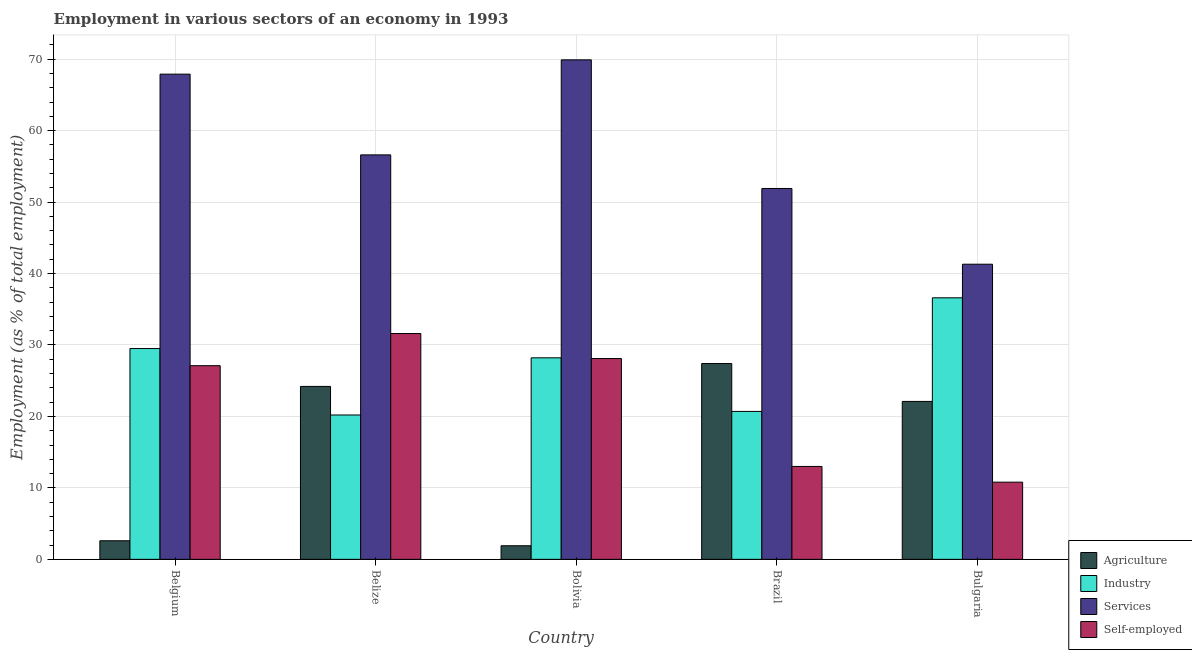Are the number of bars on each tick of the X-axis equal?
Provide a succinct answer. Yes. How many bars are there on the 5th tick from the right?
Keep it short and to the point. 4. What is the label of the 1st group of bars from the left?
Give a very brief answer. Belgium. In how many cases, is the number of bars for a given country not equal to the number of legend labels?
Provide a short and direct response. 0. What is the percentage of workers in agriculture in Belgium?
Keep it short and to the point. 2.6. Across all countries, what is the maximum percentage of workers in industry?
Ensure brevity in your answer.  36.6. Across all countries, what is the minimum percentage of workers in agriculture?
Your response must be concise. 1.9. In which country was the percentage of workers in services minimum?
Offer a terse response. Bulgaria. What is the total percentage of workers in agriculture in the graph?
Keep it short and to the point. 78.2. What is the difference between the percentage of self employed workers in Belgium and that in Bulgaria?
Offer a very short reply. 16.3. What is the difference between the percentage of workers in industry in Bolivia and the percentage of workers in services in Brazil?
Offer a terse response. -23.7. What is the average percentage of workers in services per country?
Provide a succinct answer. 57.52. What is the difference between the percentage of self employed workers and percentage of workers in services in Belize?
Ensure brevity in your answer.  -25. What is the ratio of the percentage of workers in industry in Belize to that in Brazil?
Offer a terse response. 0.98. Is the percentage of self employed workers in Belize less than that in Bolivia?
Make the answer very short. No. Is the difference between the percentage of workers in agriculture in Belgium and Bulgaria greater than the difference between the percentage of workers in services in Belgium and Bulgaria?
Offer a terse response. No. What is the difference between the highest and the second highest percentage of workers in agriculture?
Provide a short and direct response. 3.2. What is the difference between the highest and the lowest percentage of workers in services?
Your answer should be compact. 28.6. In how many countries, is the percentage of workers in industry greater than the average percentage of workers in industry taken over all countries?
Provide a short and direct response. 3. Is it the case that in every country, the sum of the percentage of workers in services and percentage of self employed workers is greater than the sum of percentage of workers in agriculture and percentage of workers in industry?
Ensure brevity in your answer.  No. What does the 3rd bar from the left in Belize represents?
Provide a succinct answer. Services. What does the 3rd bar from the right in Belize represents?
Your response must be concise. Industry. How many bars are there?
Your answer should be very brief. 20. How many countries are there in the graph?
Your answer should be very brief. 5. What is the difference between two consecutive major ticks on the Y-axis?
Offer a very short reply. 10. Are the values on the major ticks of Y-axis written in scientific E-notation?
Your answer should be compact. No. Where does the legend appear in the graph?
Give a very brief answer. Bottom right. How many legend labels are there?
Your answer should be compact. 4. What is the title of the graph?
Provide a short and direct response. Employment in various sectors of an economy in 1993. What is the label or title of the X-axis?
Provide a succinct answer. Country. What is the label or title of the Y-axis?
Offer a terse response. Employment (as % of total employment). What is the Employment (as % of total employment) of Agriculture in Belgium?
Your response must be concise. 2.6. What is the Employment (as % of total employment) in Industry in Belgium?
Keep it short and to the point. 29.5. What is the Employment (as % of total employment) of Services in Belgium?
Offer a terse response. 67.9. What is the Employment (as % of total employment) in Self-employed in Belgium?
Your answer should be very brief. 27.1. What is the Employment (as % of total employment) of Agriculture in Belize?
Provide a succinct answer. 24.2. What is the Employment (as % of total employment) in Industry in Belize?
Your answer should be compact. 20.2. What is the Employment (as % of total employment) of Services in Belize?
Offer a terse response. 56.6. What is the Employment (as % of total employment) of Self-employed in Belize?
Offer a terse response. 31.6. What is the Employment (as % of total employment) in Agriculture in Bolivia?
Your answer should be compact. 1.9. What is the Employment (as % of total employment) of Industry in Bolivia?
Make the answer very short. 28.2. What is the Employment (as % of total employment) of Services in Bolivia?
Offer a very short reply. 69.9. What is the Employment (as % of total employment) of Self-employed in Bolivia?
Provide a succinct answer. 28.1. What is the Employment (as % of total employment) in Agriculture in Brazil?
Give a very brief answer. 27.4. What is the Employment (as % of total employment) in Industry in Brazil?
Offer a terse response. 20.7. What is the Employment (as % of total employment) of Services in Brazil?
Keep it short and to the point. 51.9. What is the Employment (as % of total employment) in Agriculture in Bulgaria?
Offer a very short reply. 22.1. What is the Employment (as % of total employment) of Industry in Bulgaria?
Offer a terse response. 36.6. What is the Employment (as % of total employment) in Services in Bulgaria?
Provide a short and direct response. 41.3. What is the Employment (as % of total employment) in Self-employed in Bulgaria?
Offer a terse response. 10.8. Across all countries, what is the maximum Employment (as % of total employment) of Agriculture?
Provide a succinct answer. 27.4. Across all countries, what is the maximum Employment (as % of total employment) of Industry?
Provide a succinct answer. 36.6. Across all countries, what is the maximum Employment (as % of total employment) in Services?
Offer a terse response. 69.9. Across all countries, what is the maximum Employment (as % of total employment) in Self-employed?
Keep it short and to the point. 31.6. Across all countries, what is the minimum Employment (as % of total employment) in Agriculture?
Make the answer very short. 1.9. Across all countries, what is the minimum Employment (as % of total employment) of Industry?
Give a very brief answer. 20.2. Across all countries, what is the minimum Employment (as % of total employment) of Services?
Make the answer very short. 41.3. Across all countries, what is the minimum Employment (as % of total employment) of Self-employed?
Your answer should be compact. 10.8. What is the total Employment (as % of total employment) in Agriculture in the graph?
Offer a terse response. 78.2. What is the total Employment (as % of total employment) in Industry in the graph?
Provide a succinct answer. 135.2. What is the total Employment (as % of total employment) in Services in the graph?
Provide a succinct answer. 287.6. What is the total Employment (as % of total employment) of Self-employed in the graph?
Offer a very short reply. 110.6. What is the difference between the Employment (as % of total employment) in Agriculture in Belgium and that in Belize?
Provide a succinct answer. -21.6. What is the difference between the Employment (as % of total employment) in Services in Belgium and that in Belize?
Your response must be concise. 11.3. What is the difference between the Employment (as % of total employment) in Industry in Belgium and that in Bolivia?
Your answer should be very brief. 1.3. What is the difference between the Employment (as % of total employment) of Services in Belgium and that in Bolivia?
Your answer should be compact. -2. What is the difference between the Employment (as % of total employment) of Self-employed in Belgium and that in Bolivia?
Offer a terse response. -1. What is the difference between the Employment (as % of total employment) in Agriculture in Belgium and that in Brazil?
Provide a succinct answer. -24.8. What is the difference between the Employment (as % of total employment) of Self-employed in Belgium and that in Brazil?
Give a very brief answer. 14.1. What is the difference between the Employment (as % of total employment) in Agriculture in Belgium and that in Bulgaria?
Offer a very short reply. -19.5. What is the difference between the Employment (as % of total employment) in Industry in Belgium and that in Bulgaria?
Your answer should be compact. -7.1. What is the difference between the Employment (as % of total employment) of Services in Belgium and that in Bulgaria?
Ensure brevity in your answer.  26.6. What is the difference between the Employment (as % of total employment) of Agriculture in Belize and that in Bolivia?
Your response must be concise. 22.3. What is the difference between the Employment (as % of total employment) in Self-employed in Belize and that in Bolivia?
Your response must be concise. 3.5. What is the difference between the Employment (as % of total employment) in Agriculture in Belize and that in Brazil?
Make the answer very short. -3.2. What is the difference between the Employment (as % of total employment) in Industry in Belize and that in Brazil?
Give a very brief answer. -0.5. What is the difference between the Employment (as % of total employment) in Services in Belize and that in Brazil?
Keep it short and to the point. 4.7. What is the difference between the Employment (as % of total employment) of Self-employed in Belize and that in Brazil?
Offer a very short reply. 18.6. What is the difference between the Employment (as % of total employment) of Industry in Belize and that in Bulgaria?
Keep it short and to the point. -16.4. What is the difference between the Employment (as % of total employment) in Services in Belize and that in Bulgaria?
Make the answer very short. 15.3. What is the difference between the Employment (as % of total employment) of Self-employed in Belize and that in Bulgaria?
Ensure brevity in your answer.  20.8. What is the difference between the Employment (as % of total employment) of Agriculture in Bolivia and that in Brazil?
Your answer should be compact. -25.5. What is the difference between the Employment (as % of total employment) in Self-employed in Bolivia and that in Brazil?
Your answer should be very brief. 15.1. What is the difference between the Employment (as % of total employment) in Agriculture in Bolivia and that in Bulgaria?
Your answer should be very brief. -20.2. What is the difference between the Employment (as % of total employment) of Services in Bolivia and that in Bulgaria?
Your answer should be compact. 28.6. What is the difference between the Employment (as % of total employment) in Agriculture in Brazil and that in Bulgaria?
Offer a very short reply. 5.3. What is the difference between the Employment (as % of total employment) of Industry in Brazil and that in Bulgaria?
Offer a terse response. -15.9. What is the difference between the Employment (as % of total employment) of Self-employed in Brazil and that in Bulgaria?
Provide a short and direct response. 2.2. What is the difference between the Employment (as % of total employment) in Agriculture in Belgium and the Employment (as % of total employment) in Industry in Belize?
Offer a terse response. -17.6. What is the difference between the Employment (as % of total employment) of Agriculture in Belgium and the Employment (as % of total employment) of Services in Belize?
Your response must be concise. -54. What is the difference between the Employment (as % of total employment) of Agriculture in Belgium and the Employment (as % of total employment) of Self-employed in Belize?
Offer a terse response. -29. What is the difference between the Employment (as % of total employment) in Industry in Belgium and the Employment (as % of total employment) in Services in Belize?
Provide a succinct answer. -27.1. What is the difference between the Employment (as % of total employment) of Industry in Belgium and the Employment (as % of total employment) of Self-employed in Belize?
Offer a very short reply. -2.1. What is the difference between the Employment (as % of total employment) of Services in Belgium and the Employment (as % of total employment) of Self-employed in Belize?
Make the answer very short. 36.3. What is the difference between the Employment (as % of total employment) of Agriculture in Belgium and the Employment (as % of total employment) of Industry in Bolivia?
Offer a terse response. -25.6. What is the difference between the Employment (as % of total employment) in Agriculture in Belgium and the Employment (as % of total employment) in Services in Bolivia?
Give a very brief answer. -67.3. What is the difference between the Employment (as % of total employment) in Agriculture in Belgium and the Employment (as % of total employment) in Self-employed in Bolivia?
Make the answer very short. -25.5. What is the difference between the Employment (as % of total employment) in Industry in Belgium and the Employment (as % of total employment) in Services in Bolivia?
Give a very brief answer. -40.4. What is the difference between the Employment (as % of total employment) in Services in Belgium and the Employment (as % of total employment) in Self-employed in Bolivia?
Make the answer very short. 39.8. What is the difference between the Employment (as % of total employment) of Agriculture in Belgium and the Employment (as % of total employment) of Industry in Brazil?
Offer a terse response. -18.1. What is the difference between the Employment (as % of total employment) in Agriculture in Belgium and the Employment (as % of total employment) in Services in Brazil?
Make the answer very short. -49.3. What is the difference between the Employment (as % of total employment) of Agriculture in Belgium and the Employment (as % of total employment) of Self-employed in Brazil?
Make the answer very short. -10.4. What is the difference between the Employment (as % of total employment) of Industry in Belgium and the Employment (as % of total employment) of Services in Brazil?
Offer a terse response. -22.4. What is the difference between the Employment (as % of total employment) in Industry in Belgium and the Employment (as % of total employment) in Self-employed in Brazil?
Your answer should be very brief. 16.5. What is the difference between the Employment (as % of total employment) of Services in Belgium and the Employment (as % of total employment) of Self-employed in Brazil?
Offer a terse response. 54.9. What is the difference between the Employment (as % of total employment) of Agriculture in Belgium and the Employment (as % of total employment) of Industry in Bulgaria?
Offer a very short reply. -34. What is the difference between the Employment (as % of total employment) of Agriculture in Belgium and the Employment (as % of total employment) of Services in Bulgaria?
Make the answer very short. -38.7. What is the difference between the Employment (as % of total employment) of Services in Belgium and the Employment (as % of total employment) of Self-employed in Bulgaria?
Offer a terse response. 57.1. What is the difference between the Employment (as % of total employment) of Agriculture in Belize and the Employment (as % of total employment) of Industry in Bolivia?
Your response must be concise. -4. What is the difference between the Employment (as % of total employment) of Agriculture in Belize and the Employment (as % of total employment) of Services in Bolivia?
Your answer should be very brief. -45.7. What is the difference between the Employment (as % of total employment) of Agriculture in Belize and the Employment (as % of total employment) of Self-employed in Bolivia?
Offer a very short reply. -3.9. What is the difference between the Employment (as % of total employment) in Industry in Belize and the Employment (as % of total employment) in Services in Bolivia?
Make the answer very short. -49.7. What is the difference between the Employment (as % of total employment) in Services in Belize and the Employment (as % of total employment) in Self-employed in Bolivia?
Offer a terse response. 28.5. What is the difference between the Employment (as % of total employment) of Agriculture in Belize and the Employment (as % of total employment) of Services in Brazil?
Provide a short and direct response. -27.7. What is the difference between the Employment (as % of total employment) in Industry in Belize and the Employment (as % of total employment) in Services in Brazil?
Make the answer very short. -31.7. What is the difference between the Employment (as % of total employment) of Industry in Belize and the Employment (as % of total employment) of Self-employed in Brazil?
Ensure brevity in your answer.  7.2. What is the difference between the Employment (as % of total employment) of Services in Belize and the Employment (as % of total employment) of Self-employed in Brazil?
Your answer should be very brief. 43.6. What is the difference between the Employment (as % of total employment) of Agriculture in Belize and the Employment (as % of total employment) of Industry in Bulgaria?
Offer a very short reply. -12.4. What is the difference between the Employment (as % of total employment) of Agriculture in Belize and the Employment (as % of total employment) of Services in Bulgaria?
Offer a terse response. -17.1. What is the difference between the Employment (as % of total employment) of Agriculture in Belize and the Employment (as % of total employment) of Self-employed in Bulgaria?
Keep it short and to the point. 13.4. What is the difference between the Employment (as % of total employment) of Industry in Belize and the Employment (as % of total employment) of Services in Bulgaria?
Your response must be concise. -21.1. What is the difference between the Employment (as % of total employment) in Services in Belize and the Employment (as % of total employment) in Self-employed in Bulgaria?
Your answer should be very brief. 45.8. What is the difference between the Employment (as % of total employment) in Agriculture in Bolivia and the Employment (as % of total employment) in Industry in Brazil?
Your response must be concise. -18.8. What is the difference between the Employment (as % of total employment) of Agriculture in Bolivia and the Employment (as % of total employment) of Self-employed in Brazil?
Provide a succinct answer. -11.1. What is the difference between the Employment (as % of total employment) in Industry in Bolivia and the Employment (as % of total employment) in Services in Brazil?
Give a very brief answer. -23.7. What is the difference between the Employment (as % of total employment) of Services in Bolivia and the Employment (as % of total employment) of Self-employed in Brazil?
Make the answer very short. 56.9. What is the difference between the Employment (as % of total employment) of Agriculture in Bolivia and the Employment (as % of total employment) of Industry in Bulgaria?
Your answer should be compact. -34.7. What is the difference between the Employment (as % of total employment) of Agriculture in Bolivia and the Employment (as % of total employment) of Services in Bulgaria?
Your response must be concise. -39.4. What is the difference between the Employment (as % of total employment) in Industry in Bolivia and the Employment (as % of total employment) in Services in Bulgaria?
Your response must be concise. -13.1. What is the difference between the Employment (as % of total employment) in Services in Bolivia and the Employment (as % of total employment) in Self-employed in Bulgaria?
Your answer should be very brief. 59.1. What is the difference between the Employment (as % of total employment) in Agriculture in Brazil and the Employment (as % of total employment) in Industry in Bulgaria?
Keep it short and to the point. -9.2. What is the difference between the Employment (as % of total employment) in Agriculture in Brazil and the Employment (as % of total employment) in Services in Bulgaria?
Your response must be concise. -13.9. What is the difference between the Employment (as % of total employment) of Industry in Brazil and the Employment (as % of total employment) of Services in Bulgaria?
Your answer should be compact. -20.6. What is the difference between the Employment (as % of total employment) of Services in Brazil and the Employment (as % of total employment) of Self-employed in Bulgaria?
Your answer should be compact. 41.1. What is the average Employment (as % of total employment) of Agriculture per country?
Your answer should be very brief. 15.64. What is the average Employment (as % of total employment) of Industry per country?
Give a very brief answer. 27.04. What is the average Employment (as % of total employment) in Services per country?
Provide a short and direct response. 57.52. What is the average Employment (as % of total employment) in Self-employed per country?
Your response must be concise. 22.12. What is the difference between the Employment (as % of total employment) in Agriculture and Employment (as % of total employment) in Industry in Belgium?
Keep it short and to the point. -26.9. What is the difference between the Employment (as % of total employment) of Agriculture and Employment (as % of total employment) of Services in Belgium?
Keep it short and to the point. -65.3. What is the difference between the Employment (as % of total employment) in Agriculture and Employment (as % of total employment) in Self-employed in Belgium?
Provide a succinct answer. -24.5. What is the difference between the Employment (as % of total employment) in Industry and Employment (as % of total employment) in Services in Belgium?
Your answer should be very brief. -38.4. What is the difference between the Employment (as % of total employment) in Services and Employment (as % of total employment) in Self-employed in Belgium?
Keep it short and to the point. 40.8. What is the difference between the Employment (as % of total employment) in Agriculture and Employment (as % of total employment) in Services in Belize?
Make the answer very short. -32.4. What is the difference between the Employment (as % of total employment) in Agriculture and Employment (as % of total employment) in Self-employed in Belize?
Make the answer very short. -7.4. What is the difference between the Employment (as % of total employment) of Industry and Employment (as % of total employment) of Services in Belize?
Offer a very short reply. -36.4. What is the difference between the Employment (as % of total employment) of Industry and Employment (as % of total employment) of Self-employed in Belize?
Give a very brief answer. -11.4. What is the difference between the Employment (as % of total employment) of Agriculture and Employment (as % of total employment) of Industry in Bolivia?
Your response must be concise. -26.3. What is the difference between the Employment (as % of total employment) of Agriculture and Employment (as % of total employment) of Services in Bolivia?
Offer a terse response. -68. What is the difference between the Employment (as % of total employment) in Agriculture and Employment (as % of total employment) in Self-employed in Bolivia?
Provide a succinct answer. -26.2. What is the difference between the Employment (as % of total employment) of Industry and Employment (as % of total employment) of Services in Bolivia?
Your answer should be very brief. -41.7. What is the difference between the Employment (as % of total employment) in Services and Employment (as % of total employment) in Self-employed in Bolivia?
Offer a terse response. 41.8. What is the difference between the Employment (as % of total employment) in Agriculture and Employment (as % of total employment) in Services in Brazil?
Give a very brief answer. -24.5. What is the difference between the Employment (as % of total employment) of Agriculture and Employment (as % of total employment) of Self-employed in Brazil?
Your response must be concise. 14.4. What is the difference between the Employment (as % of total employment) in Industry and Employment (as % of total employment) in Services in Brazil?
Ensure brevity in your answer.  -31.2. What is the difference between the Employment (as % of total employment) in Industry and Employment (as % of total employment) in Self-employed in Brazil?
Make the answer very short. 7.7. What is the difference between the Employment (as % of total employment) of Services and Employment (as % of total employment) of Self-employed in Brazil?
Provide a short and direct response. 38.9. What is the difference between the Employment (as % of total employment) in Agriculture and Employment (as % of total employment) in Services in Bulgaria?
Offer a terse response. -19.2. What is the difference between the Employment (as % of total employment) in Industry and Employment (as % of total employment) in Self-employed in Bulgaria?
Give a very brief answer. 25.8. What is the difference between the Employment (as % of total employment) in Services and Employment (as % of total employment) in Self-employed in Bulgaria?
Provide a succinct answer. 30.5. What is the ratio of the Employment (as % of total employment) of Agriculture in Belgium to that in Belize?
Provide a succinct answer. 0.11. What is the ratio of the Employment (as % of total employment) of Industry in Belgium to that in Belize?
Your answer should be very brief. 1.46. What is the ratio of the Employment (as % of total employment) in Services in Belgium to that in Belize?
Provide a short and direct response. 1.2. What is the ratio of the Employment (as % of total employment) of Self-employed in Belgium to that in Belize?
Your response must be concise. 0.86. What is the ratio of the Employment (as % of total employment) in Agriculture in Belgium to that in Bolivia?
Offer a terse response. 1.37. What is the ratio of the Employment (as % of total employment) of Industry in Belgium to that in Bolivia?
Offer a terse response. 1.05. What is the ratio of the Employment (as % of total employment) of Services in Belgium to that in Bolivia?
Your answer should be compact. 0.97. What is the ratio of the Employment (as % of total employment) in Self-employed in Belgium to that in Bolivia?
Offer a terse response. 0.96. What is the ratio of the Employment (as % of total employment) of Agriculture in Belgium to that in Brazil?
Your answer should be compact. 0.09. What is the ratio of the Employment (as % of total employment) in Industry in Belgium to that in Brazil?
Your answer should be compact. 1.43. What is the ratio of the Employment (as % of total employment) in Services in Belgium to that in Brazil?
Keep it short and to the point. 1.31. What is the ratio of the Employment (as % of total employment) of Self-employed in Belgium to that in Brazil?
Your answer should be very brief. 2.08. What is the ratio of the Employment (as % of total employment) in Agriculture in Belgium to that in Bulgaria?
Give a very brief answer. 0.12. What is the ratio of the Employment (as % of total employment) in Industry in Belgium to that in Bulgaria?
Ensure brevity in your answer.  0.81. What is the ratio of the Employment (as % of total employment) of Services in Belgium to that in Bulgaria?
Provide a short and direct response. 1.64. What is the ratio of the Employment (as % of total employment) of Self-employed in Belgium to that in Bulgaria?
Your response must be concise. 2.51. What is the ratio of the Employment (as % of total employment) in Agriculture in Belize to that in Bolivia?
Offer a terse response. 12.74. What is the ratio of the Employment (as % of total employment) in Industry in Belize to that in Bolivia?
Your answer should be very brief. 0.72. What is the ratio of the Employment (as % of total employment) in Services in Belize to that in Bolivia?
Provide a short and direct response. 0.81. What is the ratio of the Employment (as % of total employment) in Self-employed in Belize to that in Bolivia?
Offer a terse response. 1.12. What is the ratio of the Employment (as % of total employment) of Agriculture in Belize to that in Brazil?
Provide a succinct answer. 0.88. What is the ratio of the Employment (as % of total employment) of Industry in Belize to that in Brazil?
Make the answer very short. 0.98. What is the ratio of the Employment (as % of total employment) of Services in Belize to that in Brazil?
Keep it short and to the point. 1.09. What is the ratio of the Employment (as % of total employment) in Self-employed in Belize to that in Brazil?
Make the answer very short. 2.43. What is the ratio of the Employment (as % of total employment) of Agriculture in Belize to that in Bulgaria?
Offer a very short reply. 1.09. What is the ratio of the Employment (as % of total employment) in Industry in Belize to that in Bulgaria?
Keep it short and to the point. 0.55. What is the ratio of the Employment (as % of total employment) in Services in Belize to that in Bulgaria?
Your answer should be very brief. 1.37. What is the ratio of the Employment (as % of total employment) in Self-employed in Belize to that in Bulgaria?
Offer a very short reply. 2.93. What is the ratio of the Employment (as % of total employment) of Agriculture in Bolivia to that in Brazil?
Keep it short and to the point. 0.07. What is the ratio of the Employment (as % of total employment) in Industry in Bolivia to that in Brazil?
Provide a succinct answer. 1.36. What is the ratio of the Employment (as % of total employment) of Services in Bolivia to that in Brazil?
Provide a succinct answer. 1.35. What is the ratio of the Employment (as % of total employment) of Self-employed in Bolivia to that in Brazil?
Offer a very short reply. 2.16. What is the ratio of the Employment (as % of total employment) in Agriculture in Bolivia to that in Bulgaria?
Make the answer very short. 0.09. What is the ratio of the Employment (as % of total employment) of Industry in Bolivia to that in Bulgaria?
Provide a short and direct response. 0.77. What is the ratio of the Employment (as % of total employment) of Services in Bolivia to that in Bulgaria?
Your answer should be very brief. 1.69. What is the ratio of the Employment (as % of total employment) in Self-employed in Bolivia to that in Bulgaria?
Offer a terse response. 2.6. What is the ratio of the Employment (as % of total employment) of Agriculture in Brazil to that in Bulgaria?
Offer a very short reply. 1.24. What is the ratio of the Employment (as % of total employment) of Industry in Brazil to that in Bulgaria?
Offer a very short reply. 0.57. What is the ratio of the Employment (as % of total employment) of Services in Brazil to that in Bulgaria?
Give a very brief answer. 1.26. What is the ratio of the Employment (as % of total employment) of Self-employed in Brazil to that in Bulgaria?
Give a very brief answer. 1.2. What is the difference between the highest and the second highest Employment (as % of total employment) of Agriculture?
Your answer should be very brief. 3.2. What is the difference between the highest and the second highest Employment (as % of total employment) in Industry?
Your answer should be compact. 7.1. What is the difference between the highest and the second highest Employment (as % of total employment) in Self-employed?
Offer a terse response. 3.5. What is the difference between the highest and the lowest Employment (as % of total employment) in Agriculture?
Your answer should be compact. 25.5. What is the difference between the highest and the lowest Employment (as % of total employment) of Industry?
Your answer should be very brief. 16.4. What is the difference between the highest and the lowest Employment (as % of total employment) of Services?
Ensure brevity in your answer.  28.6. What is the difference between the highest and the lowest Employment (as % of total employment) in Self-employed?
Offer a very short reply. 20.8. 